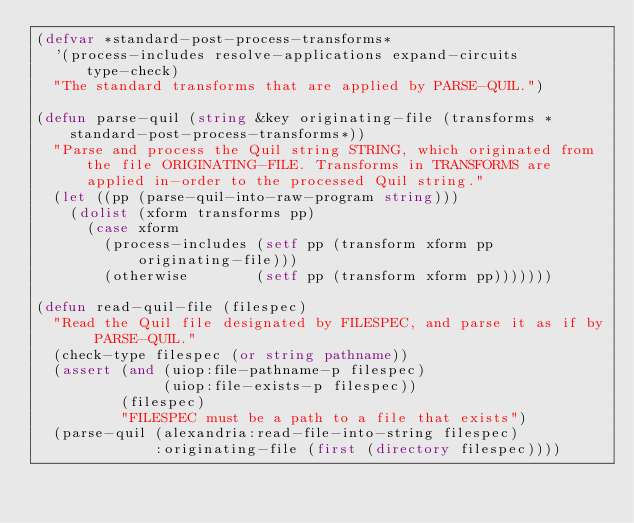<code> <loc_0><loc_0><loc_500><loc_500><_Lisp_>(defvar *standard-post-process-transforms*
  '(process-includes resolve-applications expand-circuits type-check)
  "The standard transforms that are applied by PARSE-QUIL.")

(defun parse-quil (string &key originating-file (transforms *standard-post-process-transforms*))
  "Parse and process the Quil string STRING, which originated from the file ORIGINATING-FILE. Transforms in TRANSFORMS are applied in-order to the processed Quil string."
  (let ((pp (parse-quil-into-raw-program string)))
    (dolist (xform transforms pp)
      (case xform
        (process-includes (setf pp (transform xform pp originating-file)))
        (otherwise        (setf pp (transform xform pp)))))))

(defun read-quil-file (filespec)
  "Read the Quil file designated by FILESPEC, and parse it as if by PARSE-QUIL."
  (check-type filespec (or string pathname))
  (assert (and (uiop:file-pathname-p filespec)
               (uiop:file-exists-p filespec))
          (filespec)
          "FILESPEC must be a path to a file that exists")
  (parse-quil (alexandria:read-file-into-string filespec)
              :originating-file (first (directory filespec))))
</code> 